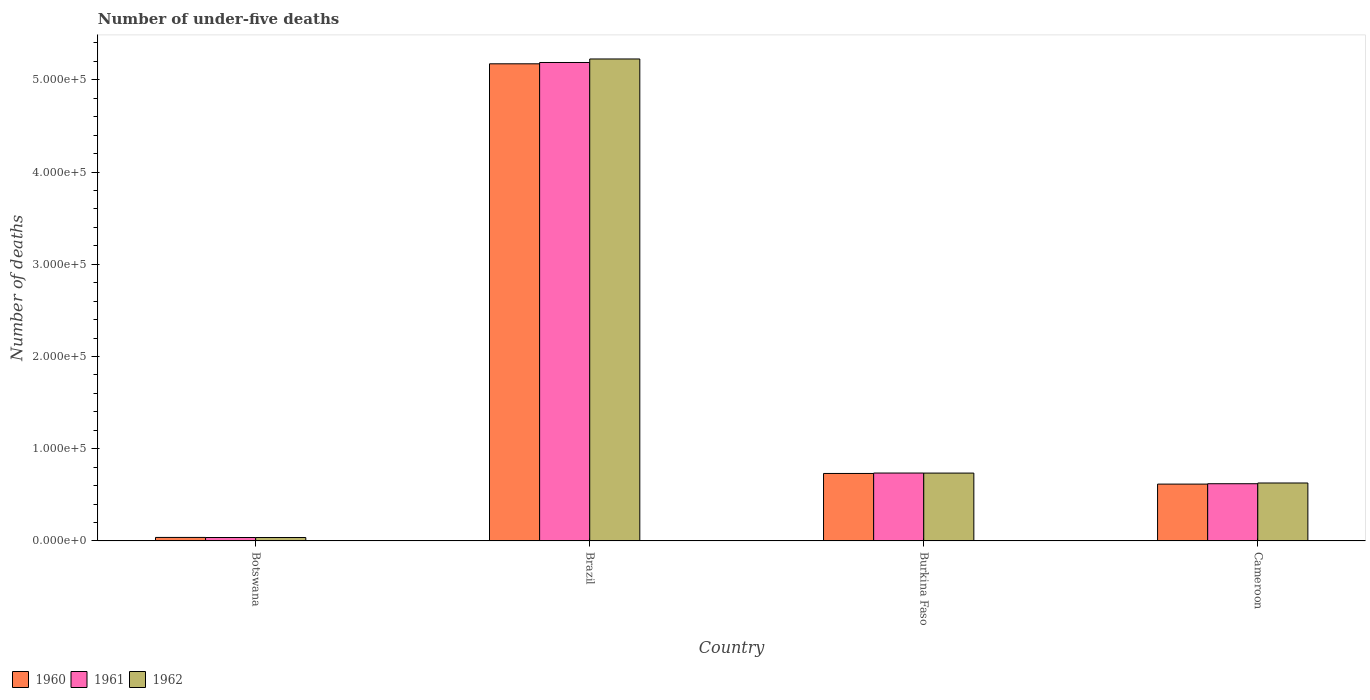How many different coloured bars are there?
Provide a short and direct response. 3. What is the label of the 2nd group of bars from the left?
Ensure brevity in your answer.  Brazil. What is the number of under-five deaths in 1961 in Brazil?
Your answer should be very brief. 5.19e+05. Across all countries, what is the maximum number of under-five deaths in 1960?
Ensure brevity in your answer.  5.17e+05. Across all countries, what is the minimum number of under-five deaths in 1961?
Ensure brevity in your answer.  3727. In which country was the number of under-five deaths in 1961 minimum?
Your response must be concise. Botswana. What is the total number of under-five deaths in 1962 in the graph?
Make the answer very short. 6.63e+05. What is the difference between the number of under-five deaths in 1960 in Brazil and that in Cameroon?
Ensure brevity in your answer.  4.56e+05. What is the difference between the number of under-five deaths in 1960 in Botswana and the number of under-five deaths in 1962 in Burkina Faso?
Your answer should be very brief. -6.98e+04. What is the average number of under-five deaths in 1960 per country?
Offer a very short reply. 1.64e+05. What is the difference between the number of under-five deaths of/in 1961 and number of under-five deaths of/in 1960 in Cameroon?
Your answer should be very brief. 396. What is the ratio of the number of under-five deaths in 1962 in Burkina Faso to that in Cameroon?
Keep it short and to the point. 1.17. Is the number of under-five deaths in 1962 in Brazil less than that in Cameroon?
Provide a succinct answer. No. Is the difference between the number of under-five deaths in 1961 in Botswana and Brazil greater than the difference between the number of under-five deaths in 1960 in Botswana and Brazil?
Keep it short and to the point. No. What is the difference between the highest and the second highest number of under-five deaths in 1960?
Keep it short and to the point. -4.56e+05. What is the difference between the highest and the lowest number of under-five deaths in 1962?
Your answer should be very brief. 5.19e+05. What does the 3rd bar from the left in Botswana represents?
Offer a very short reply. 1962. Is it the case that in every country, the sum of the number of under-five deaths in 1960 and number of under-five deaths in 1962 is greater than the number of under-five deaths in 1961?
Provide a succinct answer. Yes. How many countries are there in the graph?
Ensure brevity in your answer.  4. What is the difference between two consecutive major ticks on the Y-axis?
Offer a terse response. 1.00e+05. Does the graph contain any zero values?
Provide a succinct answer. No. Does the graph contain grids?
Give a very brief answer. No. How many legend labels are there?
Provide a succinct answer. 3. What is the title of the graph?
Give a very brief answer. Number of under-five deaths. Does "2012" appear as one of the legend labels in the graph?
Your answer should be very brief. No. What is the label or title of the X-axis?
Your answer should be compact. Country. What is the label or title of the Y-axis?
Ensure brevity in your answer.  Number of deaths. What is the Number of deaths in 1960 in Botswana?
Provide a succinct answer. 3811. What is the Number of deaths of 1961 in Botswana?
Ensure brevity in your answer.  3727. What is the Number of deaths in 1962 in Botswana?
Make the answer very short. 3708. What is the Number of deaths in 1960 in Brazil?
Your answer should be very brief. 5.17e+05. What is the Number of deaths in 1961 in Brazil?
Your answer should be compact. 5.19e+05. What is the Number of deaths of 1962 in Brazil?
Give a very brief answer. 5.23e+05. What is the Number of deaths of 1960 in Burkina Faso?
Your answer should be compact. 7.32e+04. What is the Number of deaths in 1961 in Burkina Faso?
Your response must be concise. 7.36e+04. What is the Number of deaths in 1962 in Burkina Faso?
Make the answer very short. 7.36e+04. What is the Number of deaths of 1960 in Cameroon?
Your response must be concise. 6.16e+04. What is the Number of deaths in 1961 in Cameroon?
Give a very brief answer. 6.20e+04. What is the Number of deaths in 1962 in Cameroon?
Offer a very short reply. 6.28e+04. Across all countries, what is the maximum Number of deaths in 1960?
Provide a short and direct response. 5.17e+05. Across all countries, what is the maximum Number of deaths of 1961?
Your answer should be very brief. 5.19e+05. Across all countries, what is the maximum Number of deaths in 1962?
Offer a terse response. 5.23e+05. Across all countries, what is the minimum Number of deaths in 1960?
Make the answer very short. 3811. Across all countries, what is the minimum Number of deaths in 1961?
Keep it short and to the point. 3727. Across all countries, what is the minimum Number of deaths in 1962?
Offer a very short reply. 3708. What is the total Number of deaths in 1960 in the graph?
Provide a short and direct response. 6.56e+05. What is the total Number of deaths in 1961 in the graph?
Offer a terse response. 6.58e+05. What is the total Number of deaths of 1962 in the graph?
Provide a succinct answer. 6.63e+05. What is the difference between the Number of deaths in 1960 in Botswana and that in Brazil?
Keep it short and to the point. -5.14e+05. What is the difference between the Number of deaths of 1961 in Botswana and that in Brazil?
Offer a terse response. -5.15e+05. What is the difference between the Number of deaths in 1962 in Botswana and that in Brazil?
Offer a terse response. -5.19e+05. What is the difference between the Number of deaths in 1960 in Botswana and that in Burkina Faso?
Offer a very short reply. -6.94e+04. What is the difference between the Number of deaths in 1961 in Botswana and that in Burkina Faso?
Your response must be concise. -6.99e+04. What is the difference between the Number of deaths of 1962 in Botswana and that in Burkina Faso?
Keep it short and to the point. -6.99e+04. What is the difference between the Number of deaths of 1960 in Botswana and that in Cameroon?
Make the answer very short. -5.78e+04. What is the difference between the Number of deaths in 1961 in Botswana and that in Cameroon?
Provide a succinct answer. -5.83e+04. What is the difference between the Number of deaths of 1962 in Botswana and that in Cameroon?
Provide a short and direct response. -5.91e+04. What is the difference between the Number of deaths of 1960 in Brazil and that in Burkina Faso?
Your answer should be very brief. 4.44e+05. What is the difference between the Number of deaths of 1961 in Brazil and that in Burkina Faso?
Provide a short and direct response. 4.45e+05. What is the difference between the Number of deaths of 1962 in Brazil and that in Burkina Faso?
Make the answer very short. 4.49e+05. What is the difference between the Number of deaths of 1960 in Brazil and that in Cameroon?
Provide a succinct answer. 4.56e+05. What is the difference between the Number of deaths of 1961 in Brazil and that in Cameroon?
Provide a succinct answer. 4.57e+05. What is the difference between the Number of deaths in 1962 in Brazil and that in Cameroon?
Give a very brief answer. 4.60e+05. What is the difference between the Number of deaths of 1960 in Burkina Faso and that in Cameroon?
Give a very brief answer. 1.15e+04. What is the difference between the Number of deaths in 1961 in Burkina Faso and that in Cameroon?
Your answer should be compact. 1.16e+04. What is the difference between the Number of deaths of 1962 in Burkina Faso and that in Cameroon?
Your answer should be very brief. 1.08e+04. What is the difference between the Number of deaths of 1960 in Botswana and the Number of deaths of 1961 in Brazil?
Your answer should be very brief. -5.15e+05. What is the difference between the Number of deaths in 1960 in Botswana and the Number of deaths in 1962 in Brazil?
Provide a short and direct response. -5.19e+05. What is the difference between the Number of deaths in 1961 in Botswana and the Number of deaths in 1962 in Brazil?
Provide a succinct answer. -5.19e+05. What is the difference between the Number of deaths of 1960 in Botswana and the Number of deaths of 1961 in Burkina Faso?
Give a very brief answer. -6.98e+04. What is the difference between the Number of deaths in 1960 in Botswana and the Number of deaths in 1962 in Burkina Faso?
Keep it short and to the point. -6.98e+04. What is the difference between the Number of deaths of 1961 in Botswana and the Number of deaths of 1962 in Burkina Faso?
Provide a succinct answer. -6.99e+04. What is the difference between the Number of deaths in 1960 in Botswana and the Number of deaths in 1961 in Cameroon?
Your answer should be compact. -5.82e+04. What is the difference between the Number of deaths in 1960 in Botswana and the Number of deaths in 1962 in Cameroon?
Provide a short and direct response. -5.90e+04. What is the difference between the Number of deaths of 1961 in Botswana and the Number of deaths of 1962 in Cameroon?
Your answer should be very brief. -5.91e+04. What is the difference between the Number of deaths in 1960 in Brazil and the Number of deaths in 1961 in Burkina Faso?
Your answer should be compact. 4.44e+05. What is the difference between the Number of deaths in 1960 in Brazil and the Number of deaths in 1962 in Burkina Faso?
Your response must be concise. 4.44e+05. What is the difference between the Number of deaths of 1961 in Brazil and the Number of deaths of 1962 in Burkina Faso?
Provide a succinct answer. 4.45e+05. What is the difference between the Number of deaths in 1960 in Brazil and the Number of deaths in 1961 in Cameroon?
Provide a short and direct response. 4.55e+05. What is the difference between the Number of deaths in 1960 in Brazil and the Number of deaths in 1962 in Cameroon?
Provide a short and direct response. 4.55e+05. What is the difference between the Number of deaths of 1961 in Brazil and the Number of deaths of 1962 in Cameroon?
Give a very brief answer. 4.56e+05. What is the difference between the Number of deaths in 1960 in Burkina Faso and the Number of deaths in 1961 in Cameroon?
Ensure brevity in your answer.  1.11e+04. What is the difference between the Number of deaths of 1960 in Burkina Faso and the Number of deaths of 1962 in Cameroon?
Provide a succinct answer. 1.03e+04. What is the difference between the Number of deaths of 1961 in Burkina Faso and the Number of deaths of 1962 in Cameroon?
Your response must be concise. 1.08e+04. What is the average Number of deaths in 1960 per country?
Offer a very short reply. 1.64e+05. What is the average Number of deaths in 1961 per country?
Provide a short and direct response. 1.65e+05. What is the average Number of deaths of 1962 per country?
Your answer should be very brief. 1.66e+05. What is the difference between the Number of deaths in 1960 and Number of deaths in 1961 in Botswana?
Provide a succinct answer. 84. What is the difference between the Number of deaths in 1960 and Number of deaths in 1962 in Botswana?
Provide a succinct answer. 103. What is the difference between the Number of deaths of 1961 and Number of deaths of 1962 in Botswana?
Your response must be concise. 19. What is the difference between the Number of deaths of 1960 and Number of deaths of 1961 in Brazil?
Ensure brevity in your answer.  -1424. What is the difference between the Number of deaths in 1960 and Number of deaths in 1962 in Brazil?
Ensure brevity in your answer.  -5233. What is the difference between the Number of deaths in 1961 and Number of deaths in 1962 in Brazil?
Keep it short and to the point. -3809. What is the difference between the Number of deaths of 1960 and Number of deaths of 1961 in Burkina Faso?
Provide a short and direct response. -465. What is the difference between the Number of deaths in 1960 and Number of deaths in 1962 in Burkina Faso?
Your answer should be very brief. -423. What is the difference between the Number of deaths in 1961 and Number of deaths in 1962 in Burkina Faso?
Offer a terse response. 42. What is the difference between the Number of deaths in 1960 and Number of deaths in 1961 in Cameroon?
Provide a short and direct response. -396. What is the difference between the Number of deaths in 1960 and Number of deaths in 1962 in Cameroon?
Make the answer very short. -1194. What is the difference between the Number of deaths in 1961 and Number of deaths in 1962 in Cameroon?
Provide a short and direct response. -798. What is the ratio of the Number of deaths in 1960 in Botswana to that in Brazil?
Ensure brevity in your answer.  0.01. What is the ratio of the Number of deaths of 1961 in Botswana to that in Brazil?
Provide a succinct answer. 0.01. What is the ratio of the Number of deaths in 1962 in Botswana to that in Brazil?
Make the answer very short. 0.01. What is the ratio of the Number of deaths of 1960 in Botswana to that in Burkina Faso?
Your answer should be very brief. 0.05. What is the ratio of the Number of deaths of 1961 in Botswana to that in Burkina Faso?
Offer a terse response. 0.05. What is the ratio of the Number of deaths of 1962 in Botswana to that in Burkina Faso?
Your answer should be very brief. 0.05. What is the ratio of the Number of deaths in 1960 in Botswana to that in Cameroon?
Your response must be concise. 0.06. What is the ratio of the Number of deaths of 1961 in Botswana to that in Cameroon?
Your answer should be compact. 0.06. What is the ratio of the Number of deaths in 1962 in Botswana to that in Cameroon?
Ensure brevity in your answer.  0.06. What is the ratio of the Number of deaths of 1960 in Brazil to that in Burkina Faso?
Give a very brief answer. 7.07. What is the ratio of the Number of deaths of 1961 in Brazil to that in Burkina Faso?
Keep it short and to the point. 7.05. What is the ratio of the Number of deaths in 1962 in Brazil to that in Burkina Faso?
Make the answer very short. 7.1. What is the ratio of the Number of deaths in 1960 in Brazil to that in Cameroon?
Your answer should be very brief. 8.39. What is the ratio of the Number of deaths of 1961 in Brazil to that in Cameroon?
Provide a short and direct response. 8.36. What is the ratio of the Number of deaths of 1962 in Brazil to that in Cameroon?
Make the answer very short. 8.32. What is the ratio of the Number of deaths in 1960 in Burkina Faso to that in Cameroon?
Provide a succinct answer. 1.19. What is the ratio of the Number of deaths in 1961 in Burkina Faso to that in Cameroon?
Keep it short and to the point. 1.19. What is the ratio of the Number of deaths in 1962 in Burkina Faso to that in Cameroon?
Your answer should be very brief. 1.17. What is the difference between the highest and the second highest Number of deaths of 1960?
Give a very brief answer. 4.44e+05. What is the difference between the highest and the second highest Number of deaths in 1961?
Provide a succinct answer. 4.45e+05. What is the difference between the highest and the second highest Number of deaths in 1962?
Provide a short and direct response. 4.49e+05. What is the difference between the highest and the lowest Number of deaths of 1960?
Your answer should be very brief. 5.14e+05. What is the difference between the highest and the lowest Number of deaths in 1961?
Keep it short and to the point. 5.15e+05. What is the difference between the highest and the lowest Number of deaths in 1962?
Make the answer very short. 5.19e+05. 